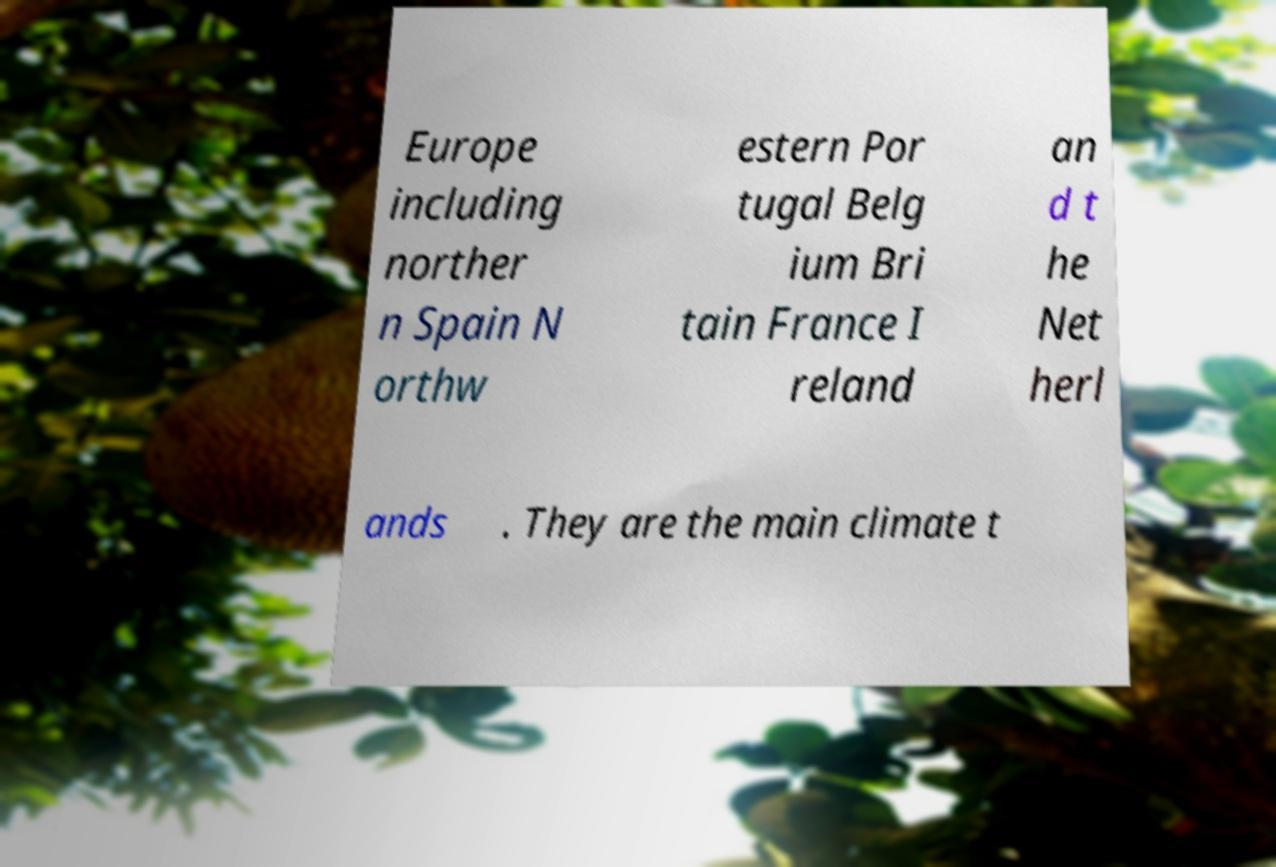Can you accurately transcribe the text from the provided image for me? Europe including norther n Spain N orthw estern Por tugal Belg ium Bri tain France I reland an d t he Net herl ands . They are the main climate t 